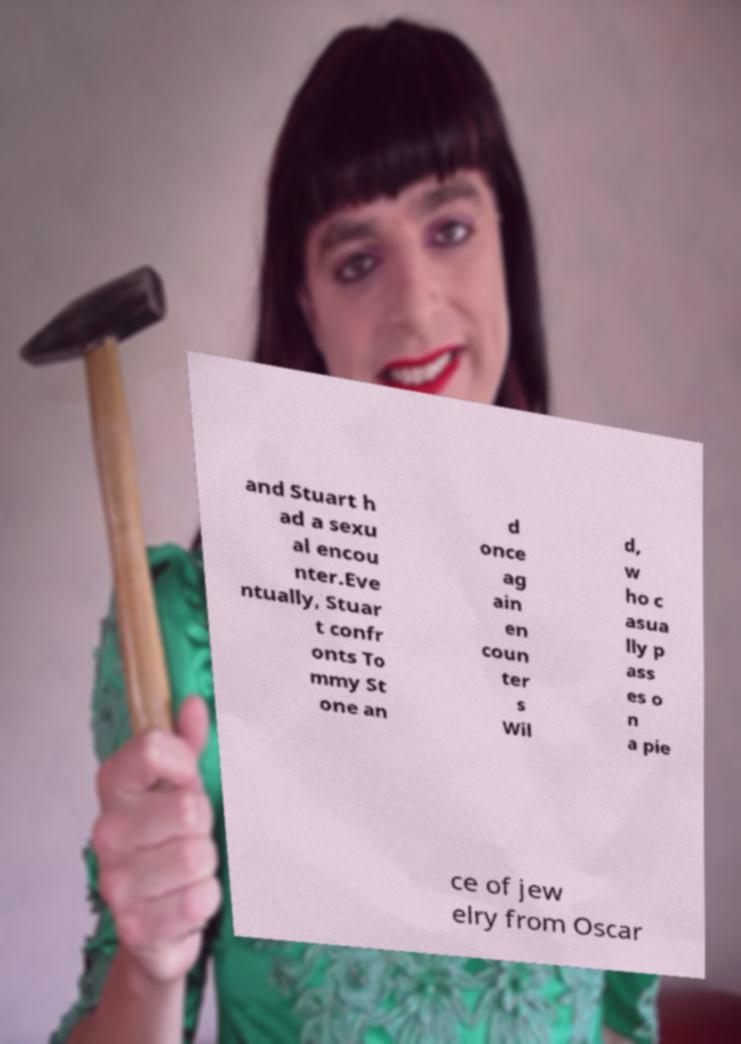Could you assist in decoding the text presented in this image and type it out clearly? and Stuart h ad a sexu al encou nter.Eve ntually, Stuar t confr onts To mmy St one an d once ag ain en coun ter s Wil d, w ho c asua lly p ass es o n a pie ce of jew elry from Oscar 